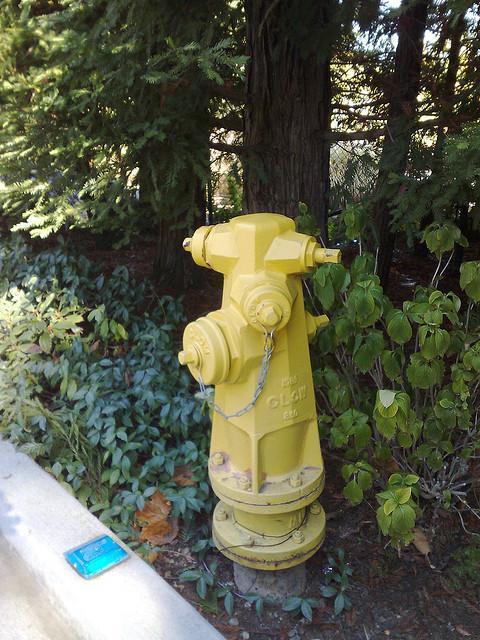How many people are on the sidewalk?
Give a very brief answer. 0. 